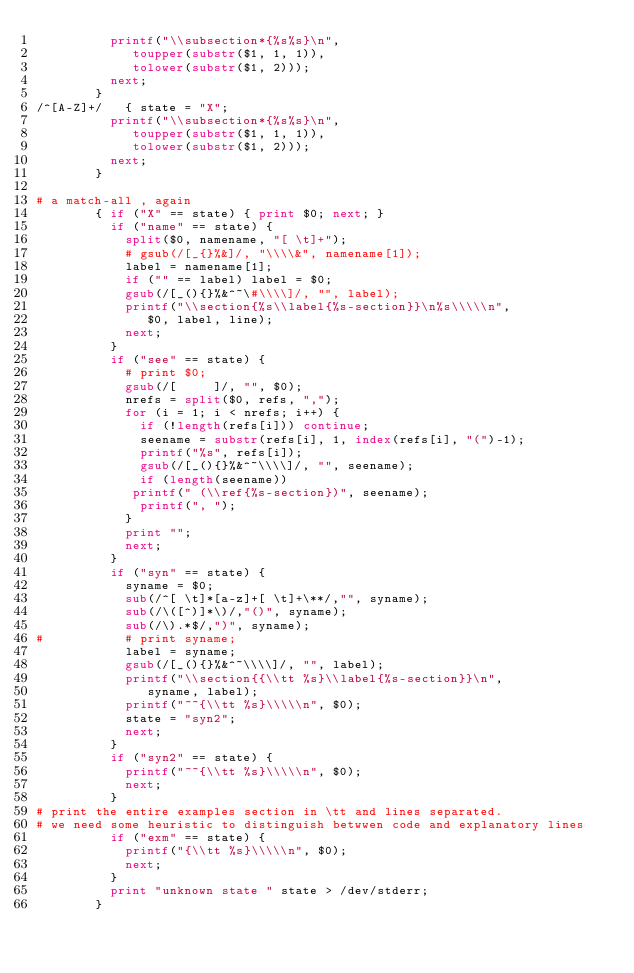Convert code to text. <code><loc_0><loc_0><loc_500><loc_500><_Awk_>		  printf("\\subsection*{%s%s}\n",
			 toupper(substr($1, 1, 1)),
			 tolower(substr($1, 2)));
		  next;
		}		
/^[A-Z]+/	{ state = "X";
		  printf("\\subsection*{%s%s}\n",
			 toupper(substr($1, 1, 1)),
			 tolower(substr($1, 2)));
		  next;
		}

# a match-all , again
		{ if ("X" == state) { print $0; next; }
		  if ("name" == state) {
		    split($0, namename, "[ \t]+");
		    # gsub(/[_{}%&]/, "\\\\&", namename[1]);
		    label = namename[1];
		    if ("" == label) label = $0;
		    gsub(/[_(){}%&^~\#\\\\]/, "", label);
		    printf("\\section{%s\\label{%s-section}}\n%s\\\\\n",
			   $0, label, line);
		    next;
		  }
		  if ("see" == state) {
		    # print $0;
		    gsub(/[ 	]/, "", $0);
		    nrefs = split($0, refs, ",");
		    for (i = 1; i < nrefs; i++) {
		      if (!length(refs[i])) continue;
		      seename = substr(refs[i], 1, index(refs[i], "(")-1);
		      printf("%s", refs[i]);
		      gsub(/[_(){}%&^~\\\\]/, "", seename);
		      if (length(seename))
			 printf(" (\\ref{%s-section})", seename);
		      printf(", ");
		    }
		    print "";			
		    next;
		  }
		  if ("syn" == state) {
		    syname = $0;
		    sub(/^[ \t]*[a-z]+[ \t]+\**/,"", syname);
		    sub(/\([^)]*\)/,"()", syname);
		    sub(/\).*$/,")", syname);
#		    # print syname;
		    label = syname;
		    gsub(/[_(){}%&^~\\\\]/, "", label);
		    printf("\\section{{\\tt %s}\\label{%s-section}}\n",
			   syname, label);
		    printf("~~{\\tt %s}\\\\\n", $0);
		    state = "syn2";
		    next;
		  }
		  if ("syn2" == state) {
		    printf("~~{\\tt %s}\\\\\n", $0);
		    next;
		  }
# print the entire examples section in \tt and lines separated.
# we need some heuristic to distinguish betwwen code and explanatory lines
		  if ("exm" == state) {
		    printf("{\\tt %s}\\\\\n", $0);
		    next;
		  }
		  print "unknown state " state > /dev/stderr;
		}
</code> 